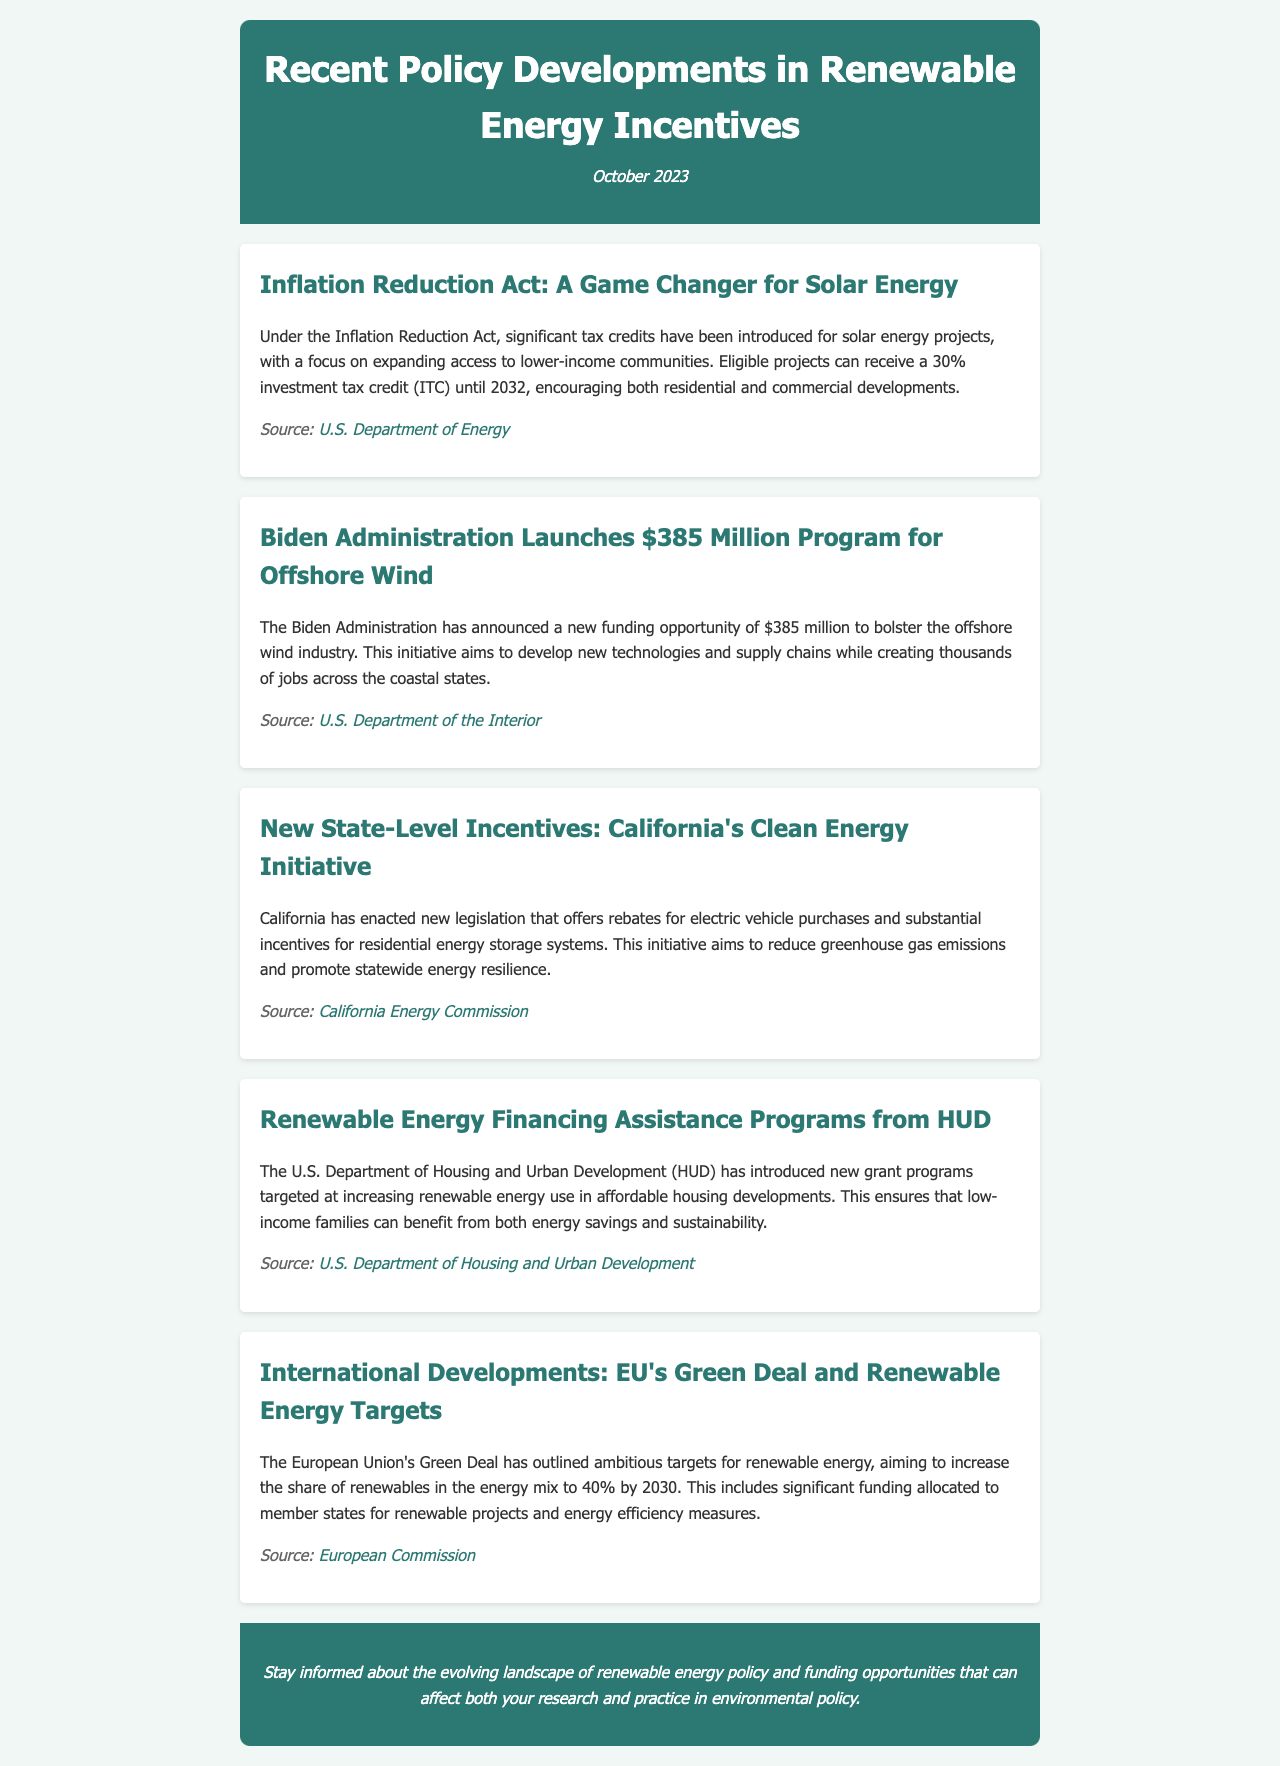What is the tax credit percentage for solar energy projects under the Inflation Reduction Act? The Inflation Reduction Act offers a 30% investment tax credit (ITC) for solar energy projects.
Answer: 30% What is the funding amount announced for the offshore wind program? The Biden Administration has announced a new funding opportunity of $385 million for the offshore wind industry.
Answer: $385 million What new incentives has California enacted for electric vehicle purchases? California's new legislation offers rebates for electric vehicle purchases.
Answer: Rebates Which department introduced new grant programs targeted at affordable housing developments? The U.S. Department of Housing and Urban Development (HUD) introduced new grant programs for renewable energy use in affordable housing.
Answer: HUD What is the renewable energy share target set by the EU's Green Deal for 2030? The EU's Green Deal aims to increase the share of renewables in the energy mix to 40% by 2030.
Answer: 40% What is the primary goal of California's Clean Energy Initiative? The initiative aims to reduce greenhouse gas emissions and promote statewide energy resilience.
Answer: Reduce emissions What are the expected outcomes of the new offshore wind funding announced by the Biden Administration? It aims to develop new technologies and supply chains while creating thousands of jobs across the coastal states.
Answer: New technologies and jobs Which year does the investment tax credit for solar energy last until? The investment tax credit for solar energy projects under the Inflation Reduction Act lasts until 2032.
Answer: 2032 